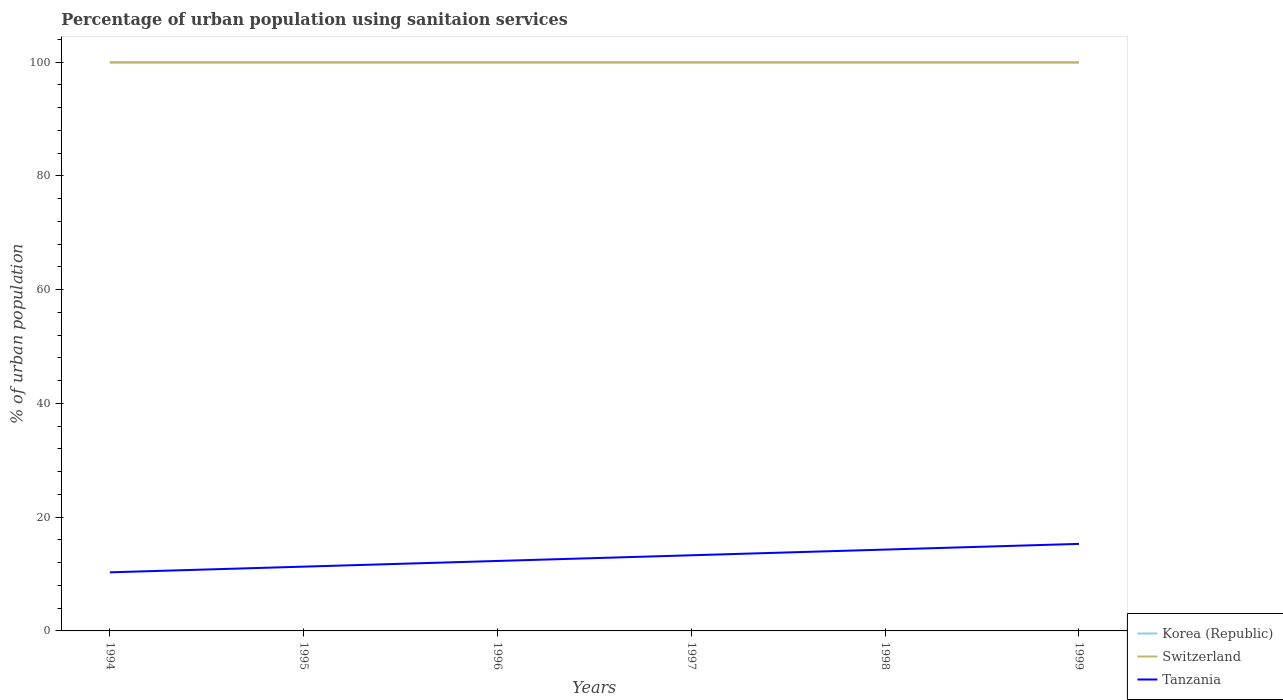Does the line corresponding to Korea (Republic) intersect with the line corresponding to Switzerland?
Provide a short and direct response. No. Across all years, what is the maximum percentage of urban population using sanitaion services in Switzerland?
Keep it short and to the point. 99.9. What is the total percentage of urban population using sanitaion services in Korea (Republic) in the graph?
Your response must be concise. 0. What is the difference between the highest and the second highest percentage of urban population using sanitaion services in Switzerland?
Give a very brief answer. 0. What is the difference between the highest and the lowest percentage of urban population using sanitaion services in Switzerland?
Give a very brief answer. 6. Is the percentage of urban population using sanitaion services in Switzerland strictly greater than the percentage of urban population using sanitaion services in Korea (Republic) over the years?
Your answer should be very brief. Yes. How many lines are there?
Your answer should be compact. 3. How many years are there in the graph?
Provide a short and direct response. 6. What is the difference between two consecutive major ticks on the Y-axis?
Give a very brief answer. 20. Are the values on the major ticks of Y-axis written in scientific E-notation?
Provide a short and direct response. No. Does the graph contain grids?
Offer a very short reply. No. Where does the legend appear in the graph?
Keep it short and to the point. Bottom right. How many legend labels are there?
Your response must be concise. 3. How are the legend labels stacked?
Ensure brevity in your answer.  Vertical. What is the title of the graph?
Offer a very short reply. Percentage of urban population using sanitaion services. Does "Tanzania" appear as one of the legend labels in the graph?
Your answer should be compact. Yes. What is the label or title of the X-axis?
Give a very brief answer. Years. What is the label or title of the Y-axis?
Make the answer very short. % of urban population. What is the % of urban population of Korea (Republic) in 1994?
Ensure brevity in your answer.  100. What is the % of urban population of Switzerland in 1994?
Ensure brevity in your answer.  99.9. What is the % of urban population of Tanzania in 1994?
Offer a very short reply. 10.3. What is the % of urban population in Switzerland in 1995?
Your answer should be compact. 99.9. What is the % of urban population of Switzerland in 1996?
Ensure brevity in your answer.  99.9. What is the % of urban population in Tanzania in 1996?
Provide a short and direct response. 12.3. What is the % of urban population of Switzerland in 1997?
Give a very brief answer. 99.9. What is the % of urban population in Tanzania in 1997?
Ensure brevity in your answer.  13.3. What is the % of urban population of Korea (Republic) in 1998?
Provide a succinct answer. 100. What is the % of urban population in Switzerland in 1998?
Provide a short and direct response. 99.9. What is the % of urban population in Tanzania in 1998?
Offer a terse response. 14.3. What is the % of urban population in Korea (Republic) in 1999?
Provide a succinct answer. 100. What is the % of urban population in Switzerland in 1999?
Your response must be concise. 99.9. Across all years, what is the maximum % of urban population in Switzerland?
Give a very brief answer. 99.9. Across all years, what is the minimum % of urban population of Korea (Republic)?
Provide a succinct answer. 100. Across all years, what is the minimum % of urban population in Switzerland?
Provide a short and direct response. 99.9. Across all years, what is the minimum % of urban population in Tanzania?
Provide a short and direct response. 10.3. What is the total % of urban population of Korea (Republic) in the graph?
Offer a terse response. 600. What is the total % of urban population of Switzerland in the graph?
Offer a terse response. 599.4. What is the total % of urban population of Tanzania in the graph?
Your response must be concise. 76.8. What is the difference between the % of urban population of Switzerland in 1994 and that in 1995?
Provide a short and direct response. 0. What is the difference between the % of urban population in Korea (Republic) in 1994 and that in 1996?
Make the answer very short. 0. What is the difference between the % of urban population in Switzerland in 1994 and that in 1996?
Ensure brevity in your answer.  0. What is the difference between the % of urban population in Korea (Republic) in 1994 and that in 1997?
Your answer should be compact. 0. What is the difference between the % of urban population of Tanzania in 1994 and that in 1997?
Give a very brief answer. -3. What is the difference between the % of urban population in Korea (Republic) in 1994 and that in 1999?
Make the answer very short. 0. What is the difference between the % of urban population of Korea (Republic) in 1995 and that in 1996?
Ensure brevity in your answer.  0. What is the difference between the % of urban population in Tanzania in 1995 and that in 1997?
Your response must be concise. -2. What is the difference between the % of urban population of Switzerland in 1995 and that in 1998?
Keep it short and to the point. 0. What is the difference between the % of urban population in Tanzania in 1995 and that in 1998?
Your answer should be compact. -3. What is the difference between the % of urban population of Korea (Republic) in 1995 and that in 1999?
Give a very brief answer. 0. What is the difference between the % of urban population of Switzerland in 1995 and that in 1999?
Give a very brief answer. 0. What is the difference between the % of urban population of Tanzania in 1996 and that in 1997?
Your answer should be very brief. -1. What is the difference between the % of urban population of Korea (Republic) in 1996 and that in 1998?
Offer a very short reply. 0. What is the difference between the % of urban population in Tanzania in 1996 and that in 1998?
Provide a short and direct response. -2. What is the difference between the % of urban population in Korea (Republic) in 1996 and that in 1999?
Your answer should be compact. 0. What is the difference between the % of urban population of Switzerland in 1996 and that in 1999?
Your response must be concise. 0. What is the difference between the % of urban population in Korea (Republic) in 1997 and that in 1998?
Your answer should be compact. 0. What is the difference between the % of urban population in Tanzania in 1998 and that in 1999?
Offer a very short reply. -1. What is the difference between the % of urban population of Korea (Republic) in 1994 and the % of urban population of Tanzania in 1995?
Offer a very short reply. 88.7. What is the difference between the % of urban population of Switzerland in 1994 and the % of urban population of Tanzania in 1995?
Provide a succinct answer. 88.6. What is the difference between the % of urban population in Korea (Republic) in 1994 and the % of urban population in Tanzania in 1996?
Your answer should be very brief. 87.7. What is the difference between the % of urban population of Switzerland in 1994 and the % of urban population of Tanzania in 1996?
Provide a short and direct response. 87.6. What is the difference between the % of urban population of Korea (Republic) in 1994 and the % of urban population of Switzerland in 1997?
Provide a succinct answer. 0.1. What is the difference between the % of urban population of Korea (Republic) in 1994 and the % of urban population of Tanzania in 1997?
Ensure brevity in your answer.  86.7. What is the difference between the % of urban population of Switzerland in 1994 and the % of urban population of Tanzania in 1997?
Your answer should be compact. 86.6. What is the difference between the % of urban population in Korea (Republic) in 1994 and the % of urban population in Switzerland in 1998?
Your answer should be very brief. 0.1. What is the difference between the % of urban population of Korea (Republic) in 1994 and the % of urban population of Tanzania in 1998?
Ensure brevity in your answer.  85.7. What is the difference between the % of urban population in Switzerland in 1994 and the % of urban population in Tanzania in 1998?
Ensure brevity in your answer.  85.6. What is the difference between the % of urban population of Korea (Republic) in 1994 and the % of urban population of Switzerland in 1999?
Your answer should be very brief. 0.1. What is the difference between the % of urban population of Korea (Republic) in 1994 and the % of urban population of Tanzania in 1999?
Ensure brevity in your answer.  84.7. What is the difference between the % of urban population of Switzerland in 1994 and the % of urban population of Tanzania in 1999?
Your answer should be compact. 84.6. What is the difference between the % of urban population in Korea (Republic) in 1995 and the % of urban population in Switzerland in 1996?
Provide a succinct answer. 0.1. What is the difference between the % of urban population of Korea (Republic) in 1995 and the % of urban population of Tanzania in 1996?
Offer a very short reply. 87.7. What is the difference between the % of urban population of Switzerland in 1995 and the % of urban population of Tanzania in 1996?
Make the answer very short. 87.6. What is the difference between the % of urban population in Korea (Republic) in 1995 and the % of urban population in Tanzania in 1997?
Keep it short and to the point. 86.7. What is the difference between the % of urban population of Switzerland in 1995 and the % of urban population of Tanzania in 1997?
Keep it short and to the point. 86.6. What is the difference between the % of urban population of Korea (Republic) in 1995 and the % of urban population of Tanzania in 1998?
Provide a succinct answer. 85.7. What is the difference between the % of urban population in Switzerland in 1995 and the % of urban population in Tanzania in 1998?
Make the answer very short. 85.6. What is the difference between the % of urban population in Korea (Republic) in 1995 and the % of urban population in Switzerland in 1999?
Offer a terse response. 0.1. What is the difference between the % of urban population in Korea (Republic) in 1995 and the % of urban population in Tanzania in 1999?
Provide a short and direct response. 84.7. What is the difference between the % of urban population of Switzerland in 1995 and the % of urban population of Tanzania in 1999?
Offer a terse response. 84.6. What is the difference between the % of urban population of Korea (Republic) in 1996 and the % of urban population of Switzerland in 1997?
Your response must be concise. 0.1. What is the difference between the % of urban population in Korea (Republic) in 1996 and the % of urban population in Tanzania in 1997?
Offer a very short reply. 86.7. What is the difference between the % of urban population in Switzerland in 1996 and the % of urban population in Tanzania in 1997?
Give a very brief answer. 86.6. What is the difference between the % of urban population of Korea (Republic) in 1996 and the % of urban population of Switzerland in 1998?
Ensure brevity in your answer.  0.1. What is the difference between the % of urban population of Korea (Republic) in 1996 and the % of urban population of Tanzania in 1998?
Your response must be concise. 85.7. What is the difference between the % of urban population in Switzerland in 1996 and the % of urban population in Tanzania in 1998?
Ensure brevity in your answer.  85.6. What is the difference between the % of urban population of Korea (Republic) in 1996 and the % of urban population of Tanzania in 1999?
Provide a short and direct response. 84.7. What is the difference between the % of urban population in Switzerland in 1996 and the % of urban population in Tanzania in 1999?
Provide a short and direct response. 84.6. What is the difference between the % of urban population of Korea (Republic) in 1997 and the % of urban population of Tanzania in 1998?
Provide a succinct answer. 85.7. What is the difference between the % of urban population in Switzerland in 1997 and the % of urban population in Tanzania in 1998?
Provide a short and direct response. 85.6. What is the difference between the % of urban population in Korea (Republic) in 1997 and the % of urban population in Tanzania in 1999?
Your answer should be very brief. 84.7. What is the difference between the % of urban population in Switzerland in 1997 and the % of urban population in Tanzania in 1999?
Keep it short and to the point. 84.6. What is the difference between the % of urban population of Korea (Republic) in 1998 and the % of urban population of Switzerland in 1999?
Your response must be concise. 0.1. What is the difference between the % of urban population in Korea (Republic) in 1998 and the % of urban population in Tanzania in 1999?
Make the answer very short. 84.7. What is the difference between the % of urban population of Switzerland in 1998 and the % of urban population of Tanzania in 1999?
Offer a terse response. 84.6. What is the average % of urban population of Korea (Republic) per year?
Make the answer very short. 100. What is the average % of urban population in Switzerland per year?
Your response must be concise. 99.9. What is the average % of urban population of Tanzania per year?
Ensure brevity in your answer.  12.8. In the year 1994, what is the difference between the % of urban population of Korea (Republic) and % of urban population of Tanzania?
Provide a succinct answer. 89.7. In the year 1994, what is the difference between the % of urban population of Switzerland and % of urban population of Tanzania?
Make the answer very short. 89.6. In the year 1995, what is the difference between the % of urban population of Korea (Republic) and % of urban population of Tanzania?
Your answer should be very brief. 88.7. In the year 1995, what is the difference between the % of urban population of Switzerland and % of urban population of Tanzania?
Offer a terse response. 88.6. In the year 1996, what is the difference between the % of urban population of Korea (Republic) and % of urban population of Tanzania?
Your answer should be compact. 87.7. In the year 1996, what is the difference between the % of urban population of Switzerland and % of urban population of Tanzania?
Your answer should be very brief. 87.6. In the year 1997, what is the difference between the % of urban population of Korea (Republic) and % of urban population of Tanzania?
Your answer should be compact. 86.7. In the year 1997, what is the difference between the % of urban population of Switzerland and % of urban population of Tanzania?
Provide a short and direct response. 86.6. In the year 1998, what is the difference between the % of urban population in Korea (Republic) and % of urban population in Switzerland?
Offer a terse response. 0.1. In the year 1998, what is the difference between the % of urban population in Korea (Republic) and % of urban population in Tanzania?
Your response must be concise. 85.7. In the year 1998, what is the difference between the % of urban population of Switzerland and % of urban population of Tanzania?
Your response must be concise. 85.6. In the year 1999, what is the difference between the % of urban population of Korea (Republic) and % of urban population of Tanzania?
Your answer should be compact. 84.7. In the year 1999, what is the difference between the % of urban population in Switzerland and % of urban population in Tanzania?
Provide a short and direct response. 84.6. What is the ratio of the % of urban population of Tanzania in 1994 to that in 1995?
Your response must be concise. 0.91. What is the ratio of the % of urban population of Korea (Republic) in 1994 to that in 1996?
Ensure brevity in your answer.  1. What is the ratio of the % of urban population in Tanzania in 1994 to that in 1996?
Give a very brief answer. 0.84. What is the ratio of the % of urban population in Korea (Republic) in 1994 to that in 1997?
Offer a terse response. 1. What is the ratio of the % of urban population of Tanzania in 1994 to that in 1997?
Provide a succinct answer. 0.77. What is the ratio of the % of urban population in Korea (Republic) in 1994 to that in 1998?
Ensure brevity in your answer.  1. What is the ratio of the % of urban population in Switzerland in 1994 to that in 1998?
Provide a succinct answer. 1. What is the ratio of the % of urban population of Tanzania in 1994 to that in 1998?
Offer a very short reply. 0.72. What is the ratio of the % of urban population in Korea (Republic) in 1994 to that in 1999?
Your answer should be very brief. 1. What is the ratio of the % of urban population in Switzerland in 1994 to that in 1999?
Your answer should be compact. 1. What is the ratio of the % of urban population of Tanzania in 1994 to that in 1999?
Give a very brief answer. 0.67. What is the ratio of the % of urban population of Korea (Republic) in 1995 to that in 1996?
Your answer should be compact. 1. What is the ratio of the % of urban population of Tanzania in 1995 to that in 1996?
Offer a very short reply. 0.92. What is the ratio of the % of urban population of Korea (Republic) in 1995 to that in 1997?
Give a very brief answer. 1. What is the ratio of the % of urban population of Tanzania in 1995 to that in 1997?
Provide a succinct answer. 0.85. What is the ratio of the % of urban population in Korea (Republic) in 1995 to that in 1998?
Your response must be concise. 1. What is the ratio of the % of urban population of Tanzania in 1995 to that in 1998?
Offer a terse response. 0.79. What is the ratio of the % of urban population in Korea (Republic) in 1995 to that in 1999?
Provide a succinct answer. 1. What is the ratio of the % of urban population of Switzerland in 1995 to that in 1999?
Give a very brief answer. 1. What is the ratio of the % of urban population in Tanzania in 1995 to that in 1999?
Offer a very short reply. 0.74. What is the ratio of the % of urban population in Korea (Republic) in 1996 to that in 1997?
Provide a succinct answer. 1. What is the ratio of the % of urban population of Tanzania in 1996 to that in 1997?
Provide a succinct answer. 0.92. What is the ratio of the % of urban population of Switzerland in 1996 to that in 1998?
Offer a terse response. 1. What is the ratio of the % of urban population in Tanzania in 1996 to that in 1998?
Your answer should be compact. 0.86. What is the ratio of the % of urban population in Korea (Republic) in 1996 to that in 1999?
Ensure brevity in your answer.  1. What is the ratio of the % of urban population in Switzerland in 1996 to that in 1999?
Provide a succinct answer. 1. What is the ratio of the % of urban population of Tanzania in 1996 to that in 1999?
Keep it short and to the point. 0.8. What is the ratio of the % of urban population in Tanzania in 1997 to that in 1998?
Provide a succinct answer. 0.93. What is the ratio of the % of urban population of Korea (Republic) in 1997 to that in 1999?
Provide a short and direct response. 1. What is the ratio of the % of urban population in Tanzania in 1997 to that in 1999?
Provide a succinct answer. 0.87. What is the ratio of the % of urban population in Korea (Republic) in 1998 to that in 1999?
Your answer should be very brief. 1. What is the ratio of the % of urban population in Tanzania in 1998 to that in 1999?
Provide a short and direct response. 0.93. What is the difference between the highest and the second highest % of urban population of Korea (Republic)?
Offer a very short reply. 0. What is the difference between the highest and the lowest % of urban population of Korea (Republic)?
Provide a succinct answer. 0. 